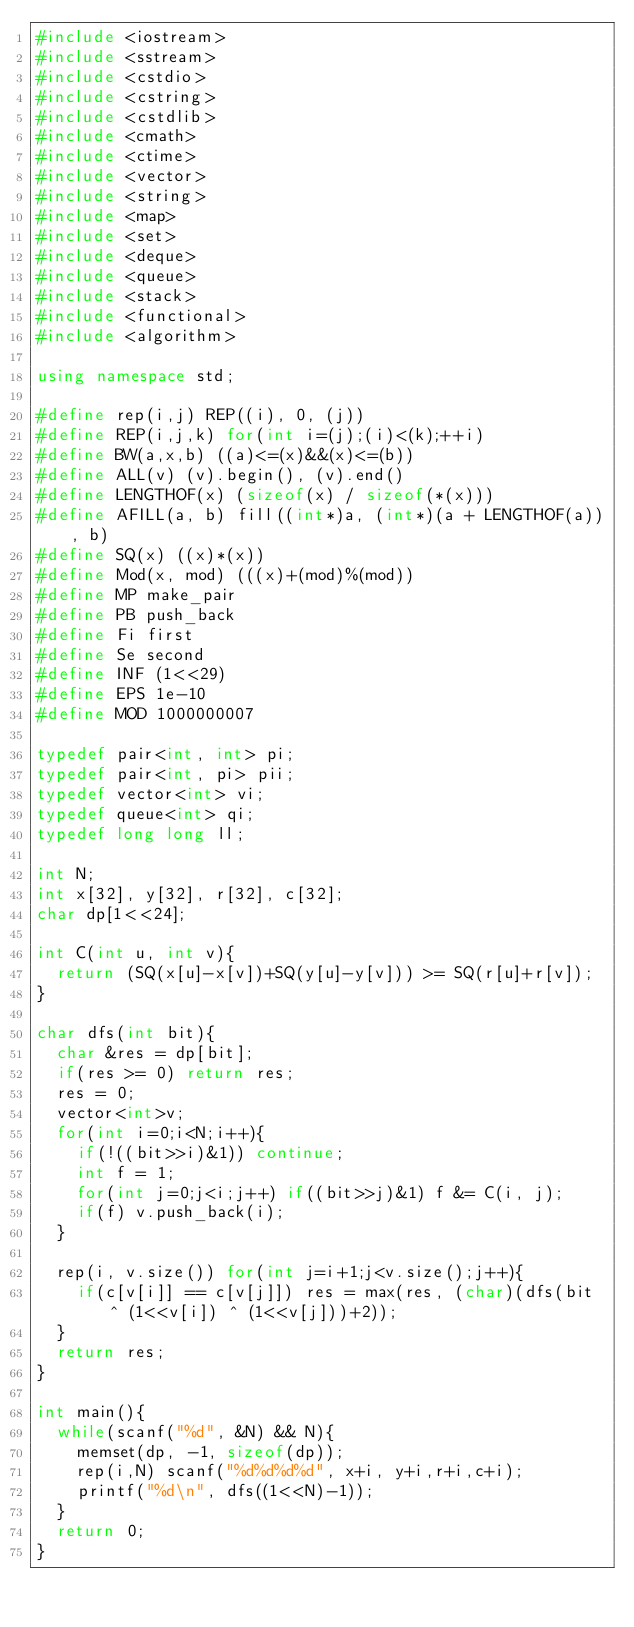Convert code to text. <code><loc_0><loc_0><loc_500><loc_500><_C++_>#include <iostream>
#include <sstream>
#include <cstdio>
#include <cstring>
#include <cstdlib>
#include <cmath>
#include <ctime>
#include <vector>
#include <string>
#include <map>
#include <set>
#include <deque>
#include <queue>
#include <stack>
#include <functional>
#include <algorithm>

using namespace std;

#define rep(i,j) REP((i), 0, (j))
#define REP(i,j,k) for(int i=(j);(i)<(k);++i)
#define BW(a,x,b) ((a)<=(x)&&(x)<=(b))
#define ALL(v) (v).begin(), (v).end()
#define LENGTHOF(x) (sizeof(x) / sizeof(*(x)))
#define AFILL(a, b) fill((int*)a, (int*)(a + LENGTHOF(a)), b)
#define SQ(x) ((x)*(x))
#define Mod(x, mod) (((x)+(mod)%(mod))
#define MP make_pair
#define PB push_back
#define Fi first
#define Se second
#define INF (1<<29)
#define EPS 1e-10
#define MOD 1000000007

typedef pair<int, int> pi;
typedef pair<int, pi> pii;
typedef vector<int> vi;
typedef queue<int> qi;
typedef long long ll;

int N;
int x[32], y[32], r[32], c[32];
char dp[1<<24];

int C(int u, int v){
  return (SQ(x[u]-x[v])+SQ(y[u]-y[v])) >= SQ(r[u]+r[v]);
}

char dfs(int bit){
  char &res = dp[bit];
  if(res >= 0) return res;
  res = 0;
  vector<int>v;
  for(int i=0;i<N;i++){
    if(!((bit>>i)&1)) continue;
    int f = 1;
    for(int j=0;j<i;j++) if((bit>>j)&1) f &= C(i, j);
    if(f) v.push_back(i);
  }

  rep(i, v.size()) for(int j=i+1;j<v.size();j++){
    if(c[v[i]] == c[v[j]]) res = max(res, (char)(dfs(bit ^ (1<<v[i]) ^ (1<<v[j]))+2));
  }
  return res;
}

int main(){
  while(scanf("%d", &N) && N){
    memset(dp, -1, sizeof(dp));
    rep(i,N) scanf("%d%d%d%d", x+i, y+i,r+i,c+i);
    printf("%d\n", dfs((1<<N)-1));
  }
  return 0;
}</code> 